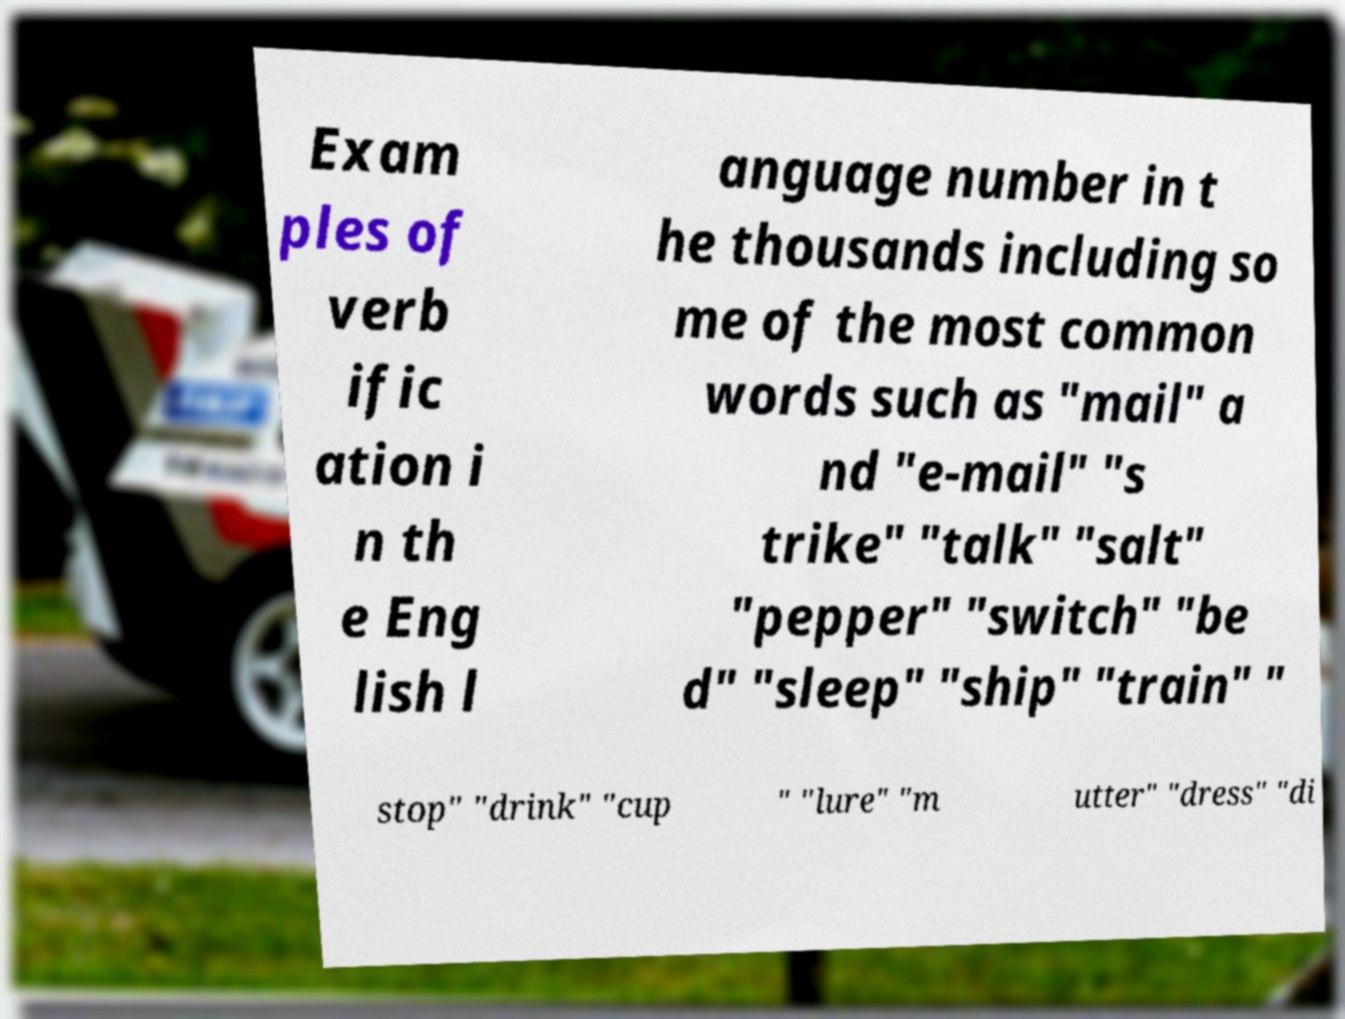Could you extract and type out the text from this image? Exam ples of verb ific ation i n th e Eng lish l anguage number in t he thousands including so me of the most common words such as "mail" a nd "e-mail" "s trike" "talk" "salt" "pepper" "switch" "be d" "sleep" "ship" "train" " stop" "drink" "cup " "lure" "m utter" "dress" "di 